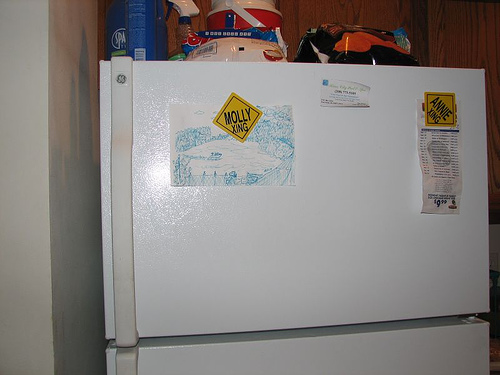<image>Whose house is this? I don't know whose house this is. It can be Molly and Annie's or Molly's house. Whose house is this? It is ambiguous whose house this is. It can be either Molly's or Annie's. 